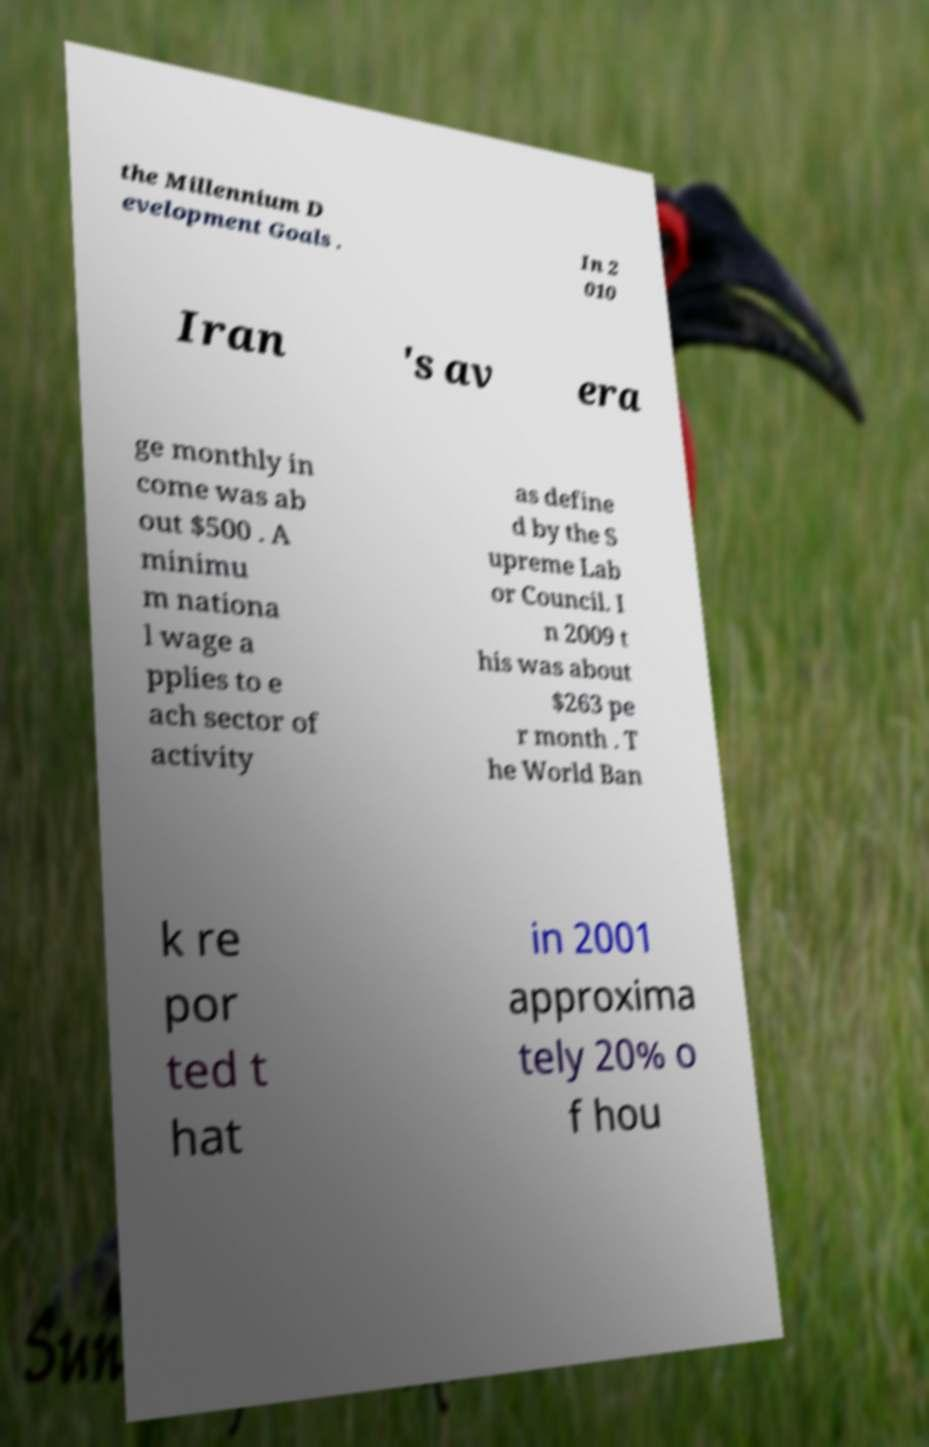Could you assist in decoding the text presented in this image and type it out clearly? the Millennium D evelopment Goals . In 2 010 Iran 's av era ge monthly in come was ab out $500 . A minimu m nationa l wage a pplies to e ach sector of activity as define d by the S upreme Lab or Council. I n 2009 t his was about $263 pe r month . T he World Ban k re por ted t hat in 2001 approxima tely 20% o f hou 